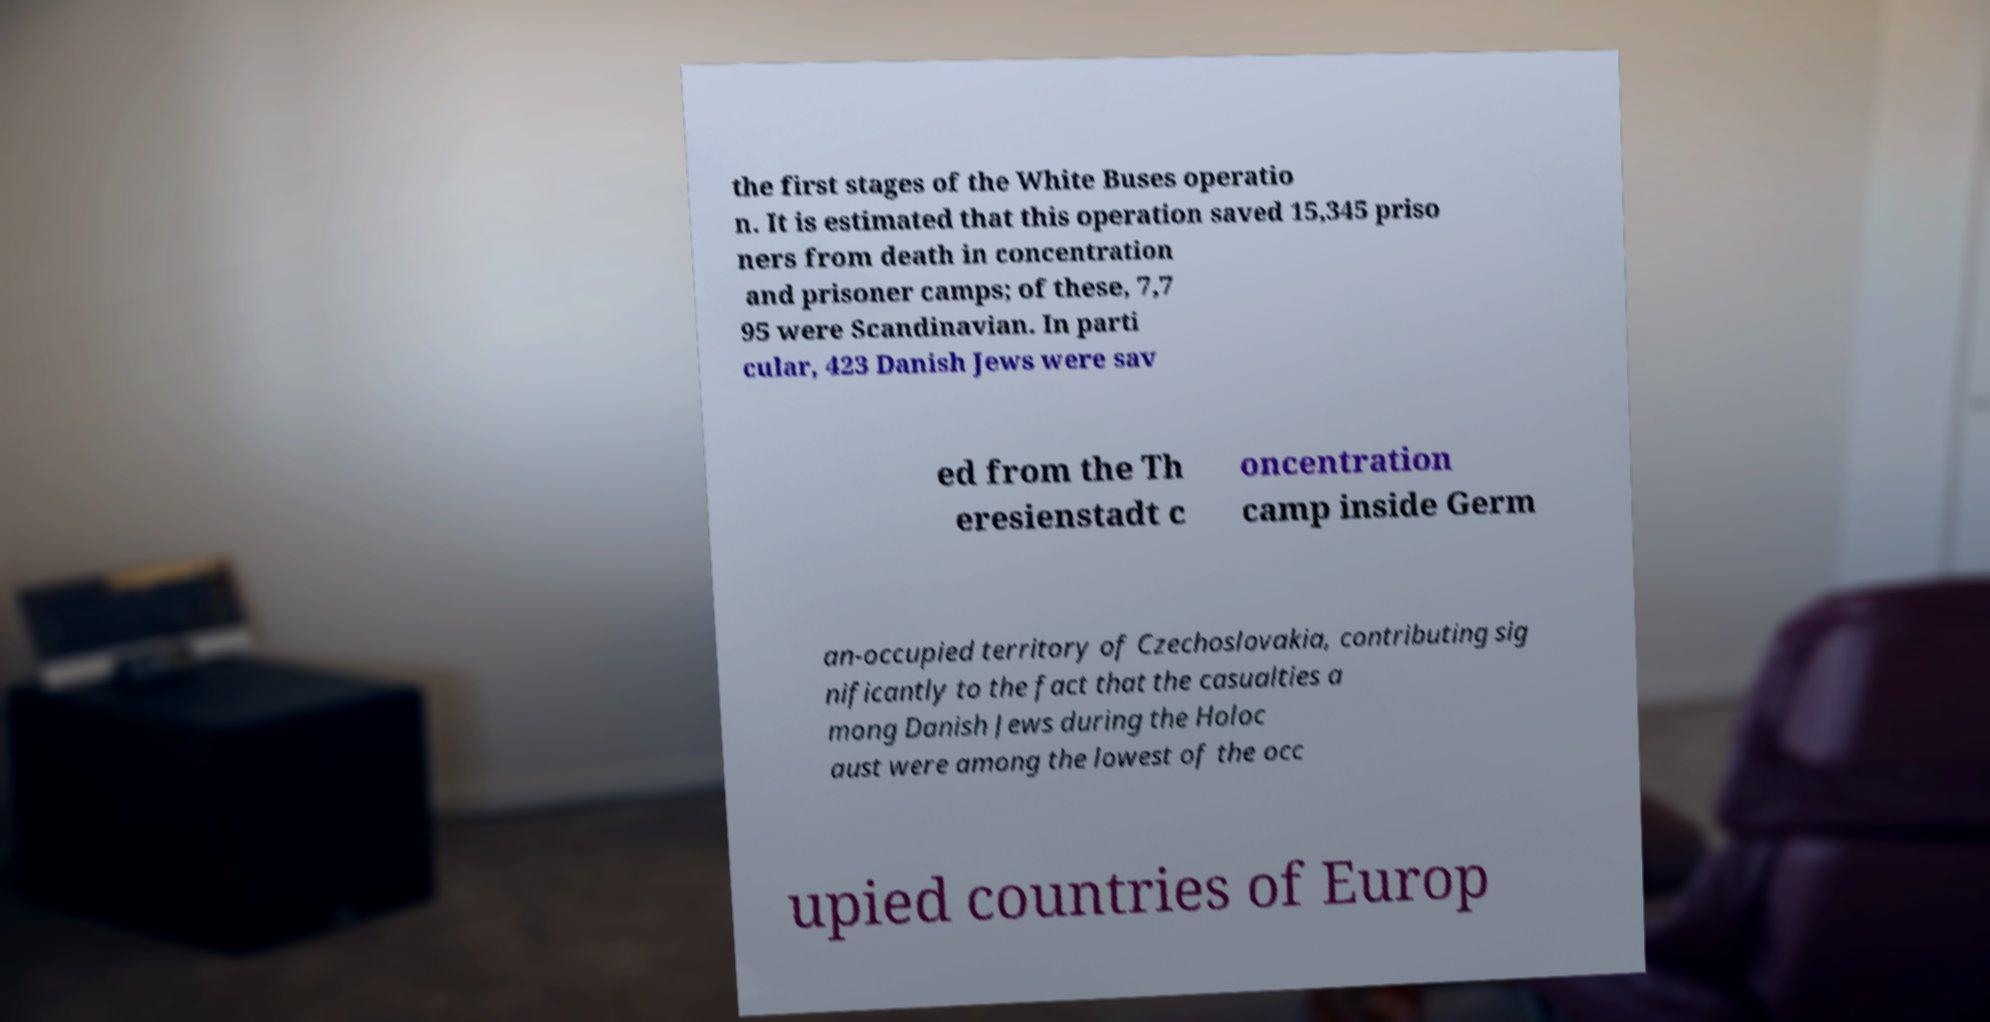There's text embedded in this image that I need extracted. Can you transcribe it verbatim? the first stages of the White Buses operatio n. It is estimated that this operation saved 15,345 priso ners from death in concentration and prisoner camps; of these, 7,7 95 were Scandinavian. In parti cular, 423 Danish Jews were sav ed from the Th eresienstadt c oncentration camp inside Germ an-occupied territory of Czechoslovakia, contributing sig nificantly to the fact that the casualties a mong Danish Jews during the Holoc aust were among the lowest of the occ upied countries of Europ 